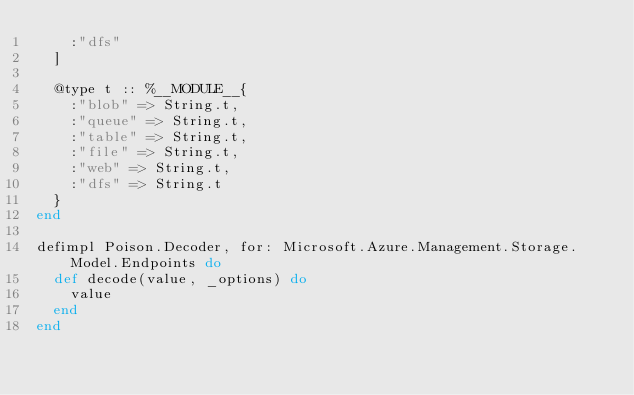Convert code to text. <code><loc_0><loc_0><loc_500><loc_500><_Elixir_>    :"dfs"
  ]

  @type t :: %__MODULE__{
    :"blob" => String.t,
    :"queue" => String.t,
    :"table" => String.t,
    :"file" => String.t,
    :"web" => String.t,
    :"dfs" => String.t
  }
end

defimpl Poison.Decoder, for: Microsoft.Azure.Management.Storage.Model.Endpoints do
  def decode(value, _options) do
    value
  end
end

</code> 